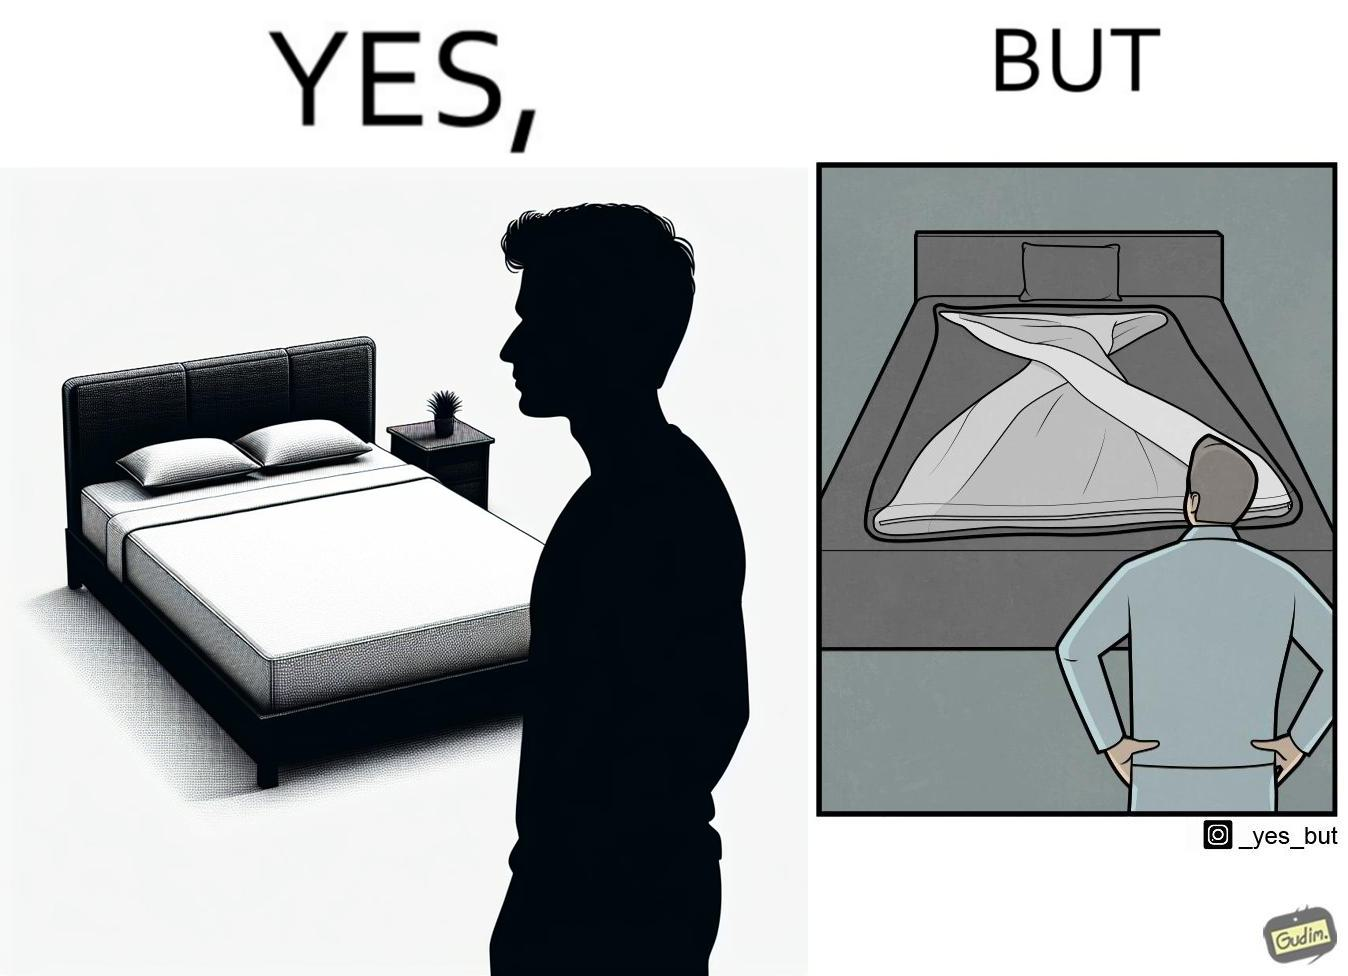Describe the satirical element in this image. The image is funny because while the bed seems to be well made with the blanket on top, the actual blanket inside the blanket cover is twisted and not properly set. 